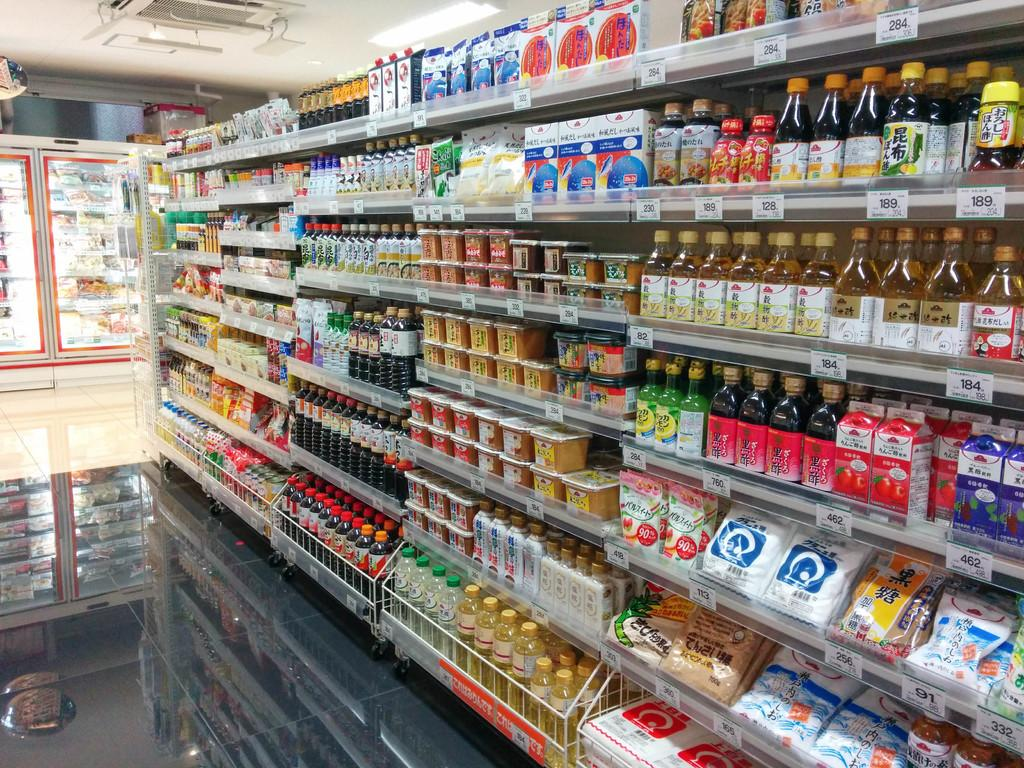What type of establishment is shown in the image? There is a supermarket in the image. What can be found inside the supermarket? There are groceries in the supermarket. What type of laborer can be seen working in the supermarket in the image? There are no laborers visible in the image; it only shows the supermarket and groceries. 